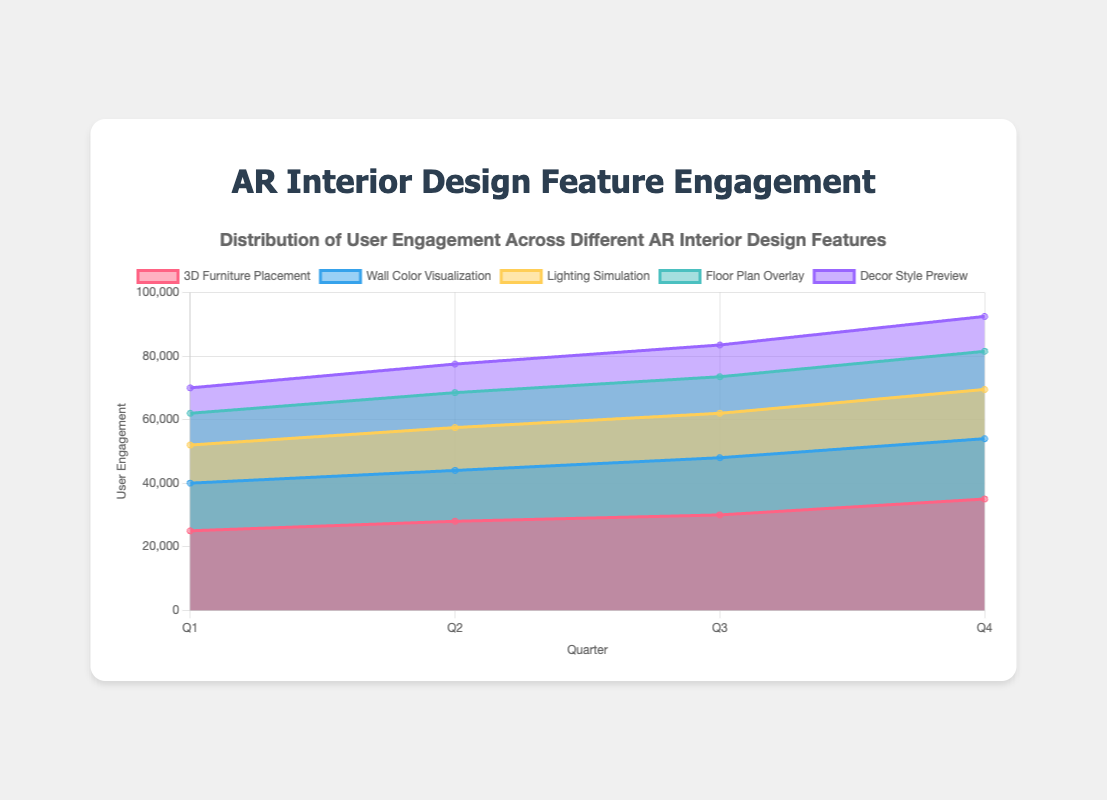What is the title of the chart? The title of the chart is located at the top and reads: "Distribution of User Engagement Across Different AR Interior Design Features".
Answer: Distribution of User Engagement Across Different AR Interior Design Features Which feature had the highest user engagement in Q4? To determine the highest user engagement in Q4, look at the Q4 values for all features. "3D Furniture Placement" has the highest value at 35,000.
Answer: 3D Furniture Placement How many quarters are represented in the chart? The x-axis lists the quarters, which are Q1, Q2, Q3, and Q4. There are a total of 4 quarters.
Answer: 4 Which feature shows the least increase in user engagement from Q1 to Q4? Calculate the difference between Q4 and Q1 for each feature and find the smallest value: - 3D Furniture Placement: 10000, Wall Color Visualization: 4000, Lighting Simulation: 3500, Floor Plan Overlay: 2000, Decor Style Preview: 3000. "Floor Plan Overlay" has the smallest increase (12000 - 10000 = 2000).
Answer: Floor Plan Overlay What is the total user engagement for "Lighting Simulation" in Q3? The chart shows that the user engagement for "Lighting Simulation" in Q3 is 14,000.
Answer: 14000 Which feature has a consistent increase in user engagement across all quarters? Check if each feature’s user engagement value steadily increases from Q1 to Q4:
- 3D Furniture Placement: Yes
- Wall Color Visualization: Yes
- Lighting Simulation: Yes
- Floor Plan Overlay: Yes
- Decor Style Preview: Yes
All features show a consistent increase.
Answer: All features Compare the user engagement of "Wall Color Visualization" and "Lighting Simulation" in Q1. Which is greater and by how much? "Wall Color Visualization" in Q1: 15,000, "Lighting Simulation" in Q1: 12,000. Difference: 15000 - 12000 = 3000. "Wall Color Visualization" is greater by 3,000.
Answer: Wall Color Visualization by 3000 How does the overall engagement trend look from Q1 to Q4 for "Decor Style Preview"? Look at the engagement numbers for "Decor Style Preview" across all quarters: Q1 is 8000, Q2 is 9000, Q3 is 10000, Q4 is 11000. The trend shows a steady increase.
Answer: Steady increase Which feature had the second highest user engagement in Q2? Compare the Q2 values for each feature. "3D Furniture Placement" is the highest (28000), and "Wall Color Visualization" is second highest (16000).
Answer: Wall Color Visualization What is the cumulative user engagement for "3D Furniture Placement" across all quarters? Sum the user engagement for "3D Furniture Placement" from Q1 to Q4: 25000 + 28000 + 30000 + 35000 = 118000.
Answer: 118000 